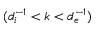<formula> <loc_0><loc_0><loc_500><loc_500>( d _ { i } ^ { - 1 } < k < d _ { e } ^ { - 1 } )</formula> 